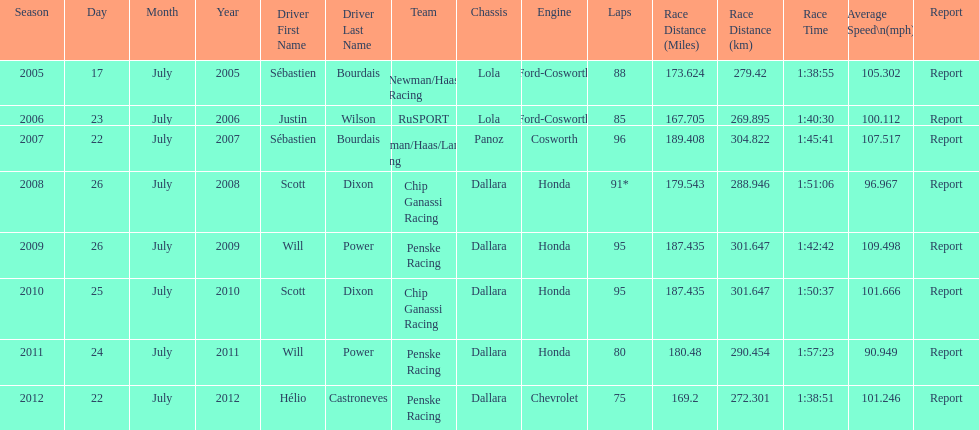How many different teams are represented in the table? 4. 